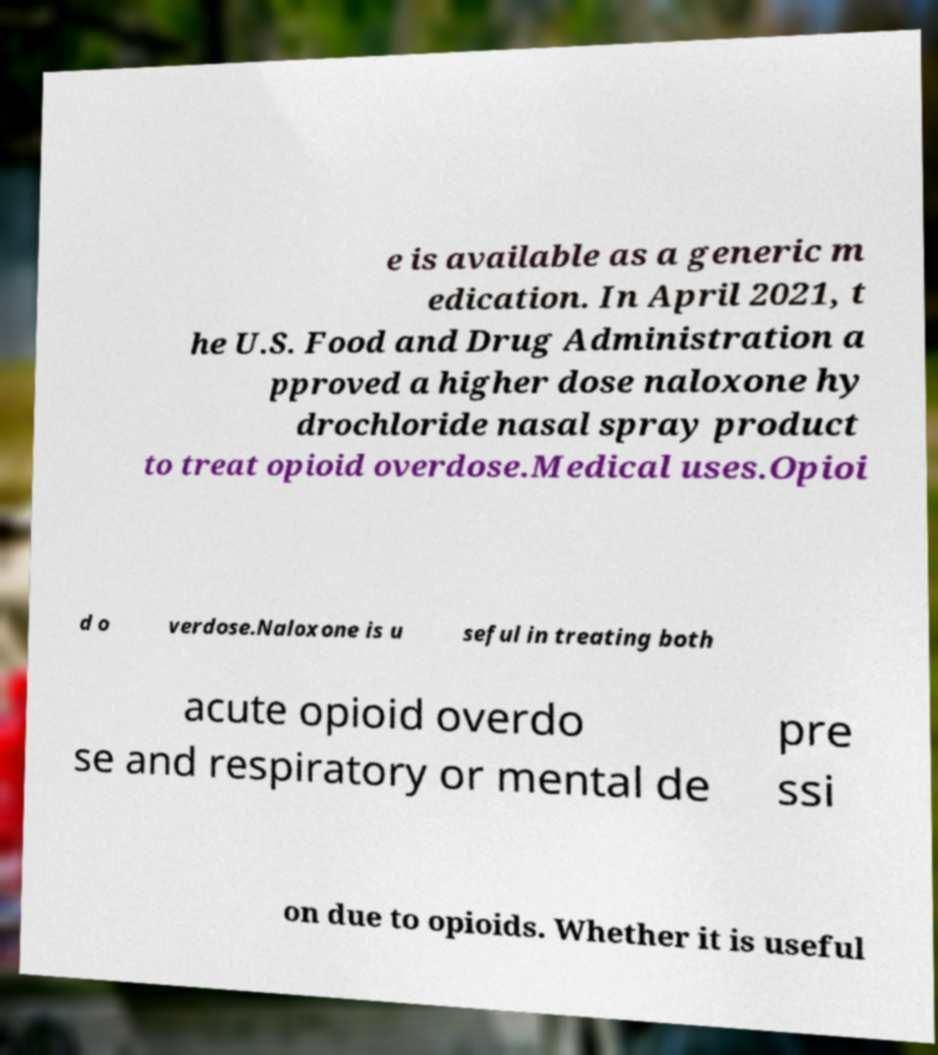Can you accurately transcribe the text from the provided image for me? e is available as a generic m edication. In April 2021, t he U.S. Food and Drug Administration a pproved a higher dose naloxone hy drochloride nasal spray product to treat opioid overdose.Medical uses.Opioi d o verdose.Naloxone is u seful in treating both acute opioid overdo se and respiratory or mental de pre ssi on due to opioids. Whether it is useful 